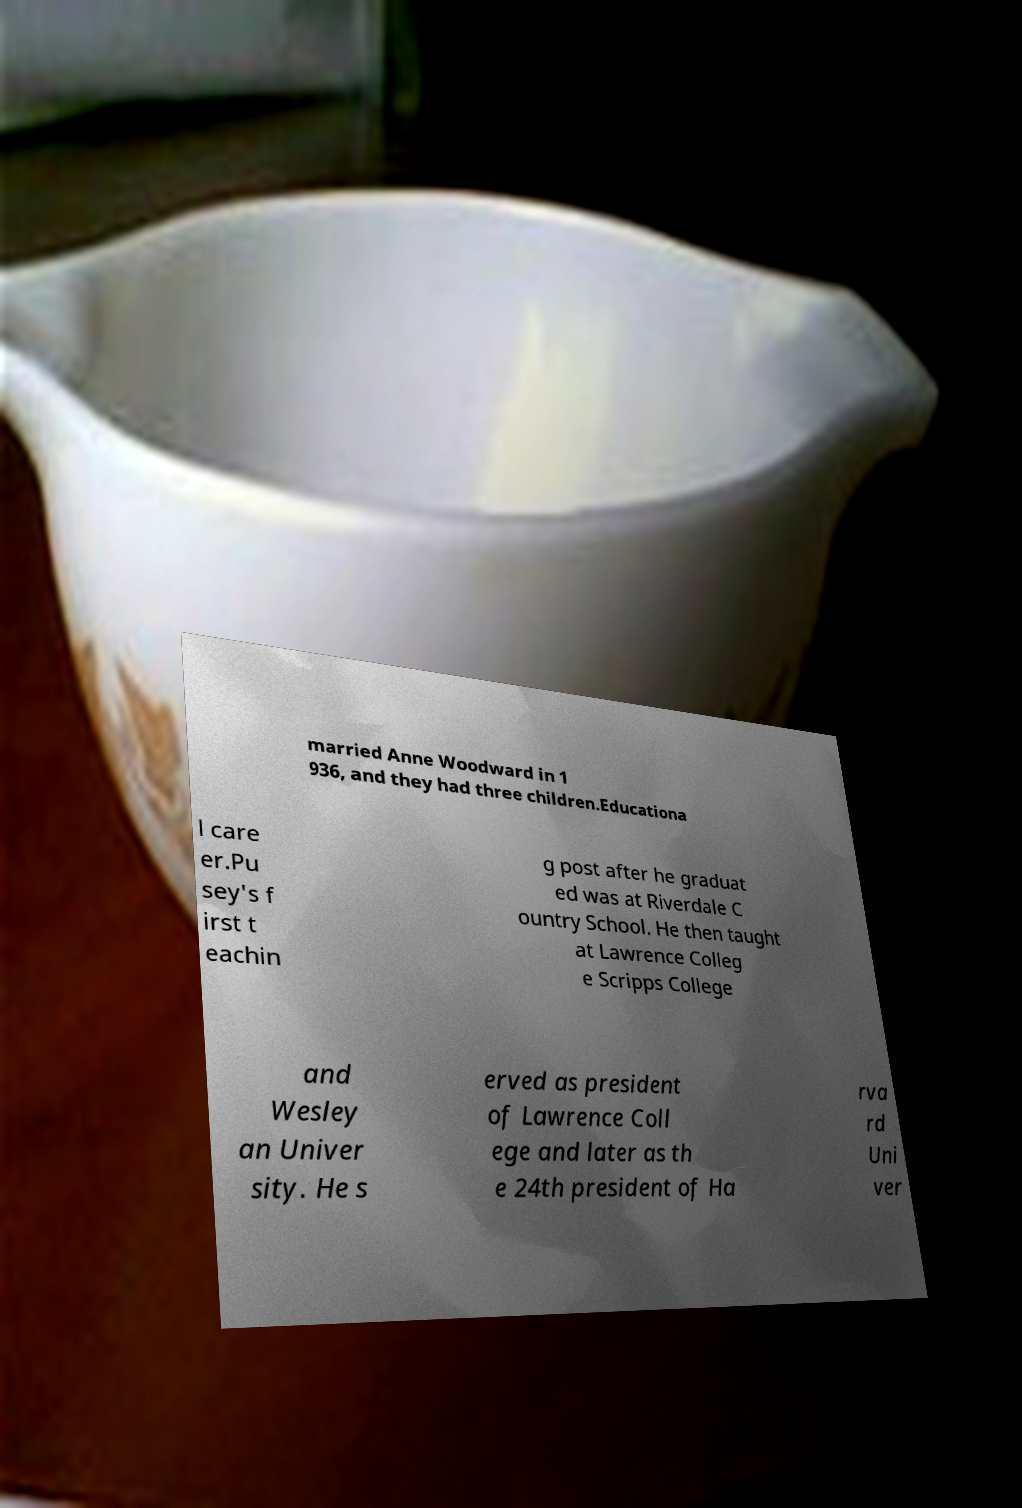Could you assist in decoding the text presented in this image and type it out clearly? married Anne Woodward in 1 936, and they had three children.Educationa l care er.Pu sey's f irst t eachin g post after he graduat ed was at Riverdale C ountry School. He then taught at Lawrence Colleg e Scripps College and Wesley an Univer sity. He s erved as president of Lawrence Coll ege and later as th e 24th president of Ha rva rd Uni ver 